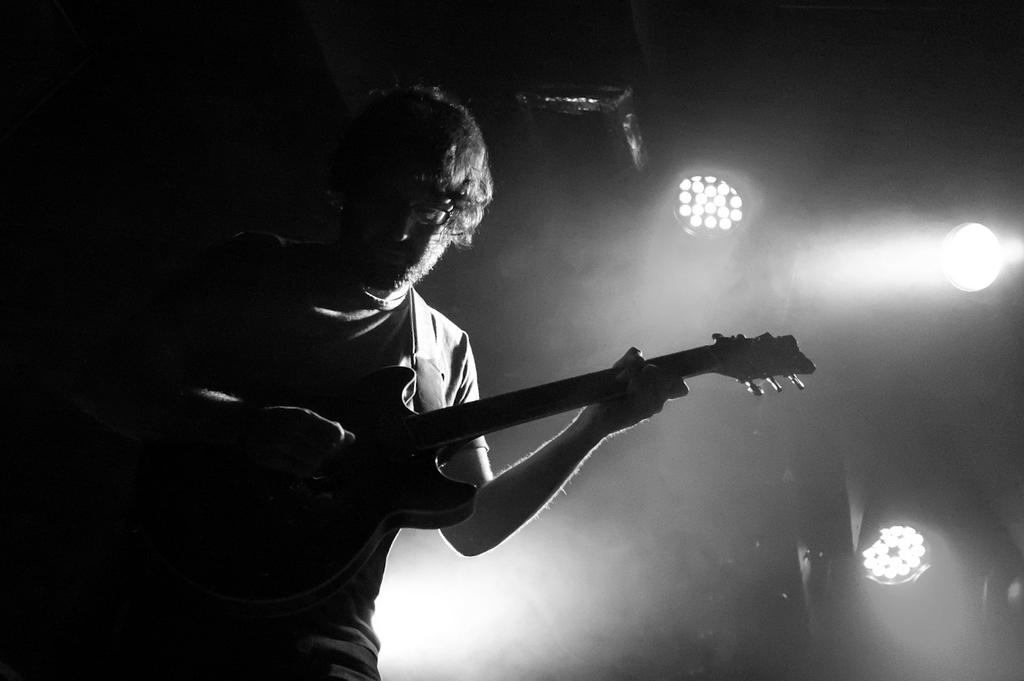What is the person in the image doing? The person is playing a guitar. Can you describe the person's appearance in the image? The person is wearing glasses. What can be seen in the background of the image? There are lights and a projector in the image. What type of office furniture is visible in the image? There is no office furniture present in the image. What dish is being served for dinner in the image? There is no dinner or food present in the image. 